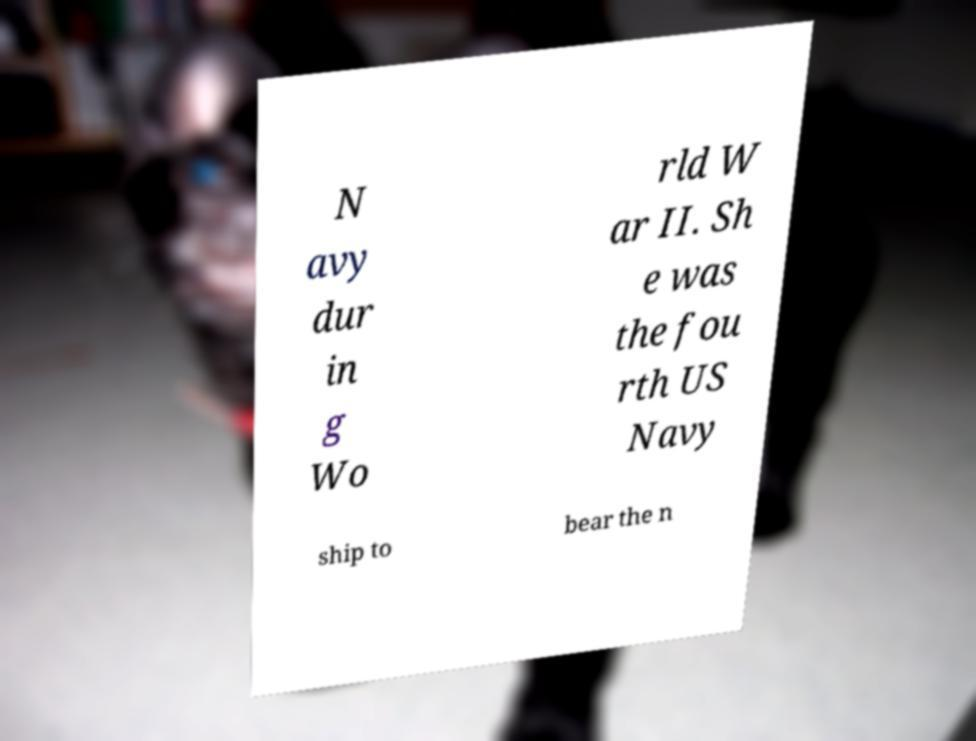There's text embedded in this image that I need extracted. Can you transcribe it verbatim? N avy dur in g Wo rld W ar II. Sh e was the fou rth US Navy ship to bear the n 